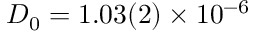<formula> <loc_0><loc_0><loc_500><loc_500>D _ { 0 } = 1 . 0 3 ( 2 ) \times 1 0 ^ { - 6 }</formula> 